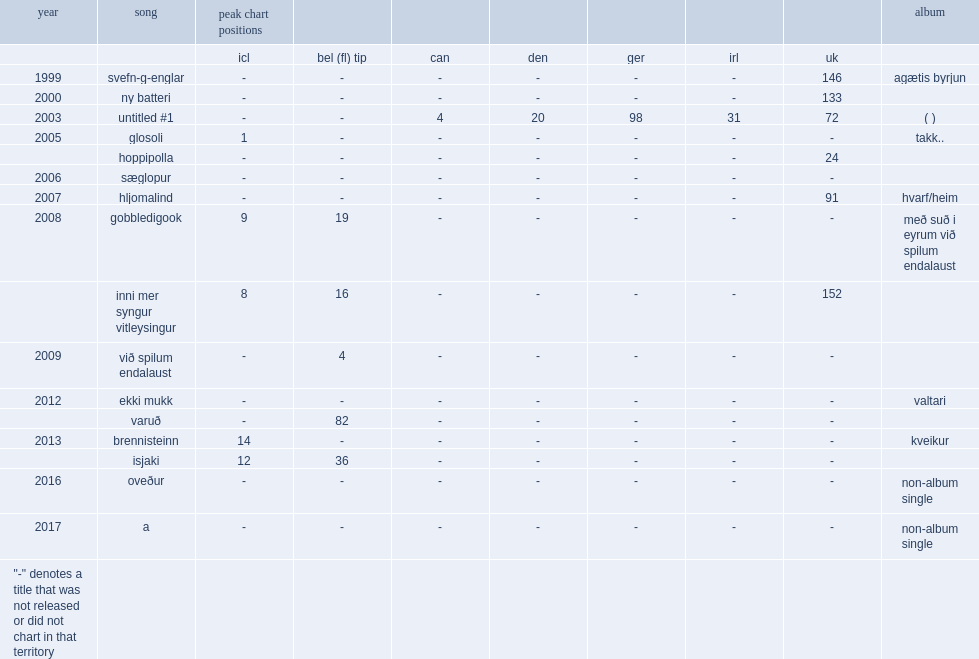When did the single "ekki mukk" release? 2012.0. Would you be able to parse every entry in this table? {'header': ['year', 'song', 'peak chart positions', '', '', '', '', '', '', 'album'], 'rows': [['', '', 'icl', 'bel (fl) tip', 'can', 'den', 'ger', 'irl', 'uk', ''], ['1999', 'svefn-g-englar', '-', '-', '-', '-', '-', '-', '146', 'agætis byrjun'], ['2000', 'ny batteri', '-', '-', '-', '-', '-', '-', '133', ''], ['2003', 'untitled #1', '-', '-', '4', '20', '98', '31', '72', '( )'], ['2005', 'glosoli', '1', '-', '-', '-', '-', '-', '-', 'takk..'], ['', 'hoppipolla', '-', '-', '-', '-', '-', '-', '24', ''], ['2006', 'sæglopur', '-', '-', '-', '-', '-', '-', '-', ''], ['2007', 'hljomalind', '-', '-', '-', '-', '-', '-', '91', 'hvarf/heim'], ['2008', 'gobbledigook', '9', '19', '-', '-', '-', '-', '-', 'með suð i eyrum við spilum endalaust'], ['', 'inni mer syngur vitleysingur', '8', '16', '-', '-', '-', '-', '152', ''], ['2009', 'við spilum endalaust', '-', '4', '-', '-', '-', '-', '-', ''], ['2012', 'ekki mukk', '-', '-', '-', '-', '-', '-', '-', 'valtari'], ['', 'varuð', '-', '82', '-', '-', '-', '-', '-', ''], ['2013', 'brennisteinn', '14', '-', '-', '-', '-', '-', '-', 'kveikur'], ['', 'isjaki', '12', '36', '-', '-', '-', '-', '-', ''], ['2016', 'oveður', '-', '-', '-', '-', '-', '-', '-', 'non-album single'], ['2017', 'a', '-', '-', '-', '-', '-', '-', '-', 'non-album single'], ['"-" denotes a title that was not released or did not chart in that territory', '', '', '', '', '', '', '', '', '']]} 